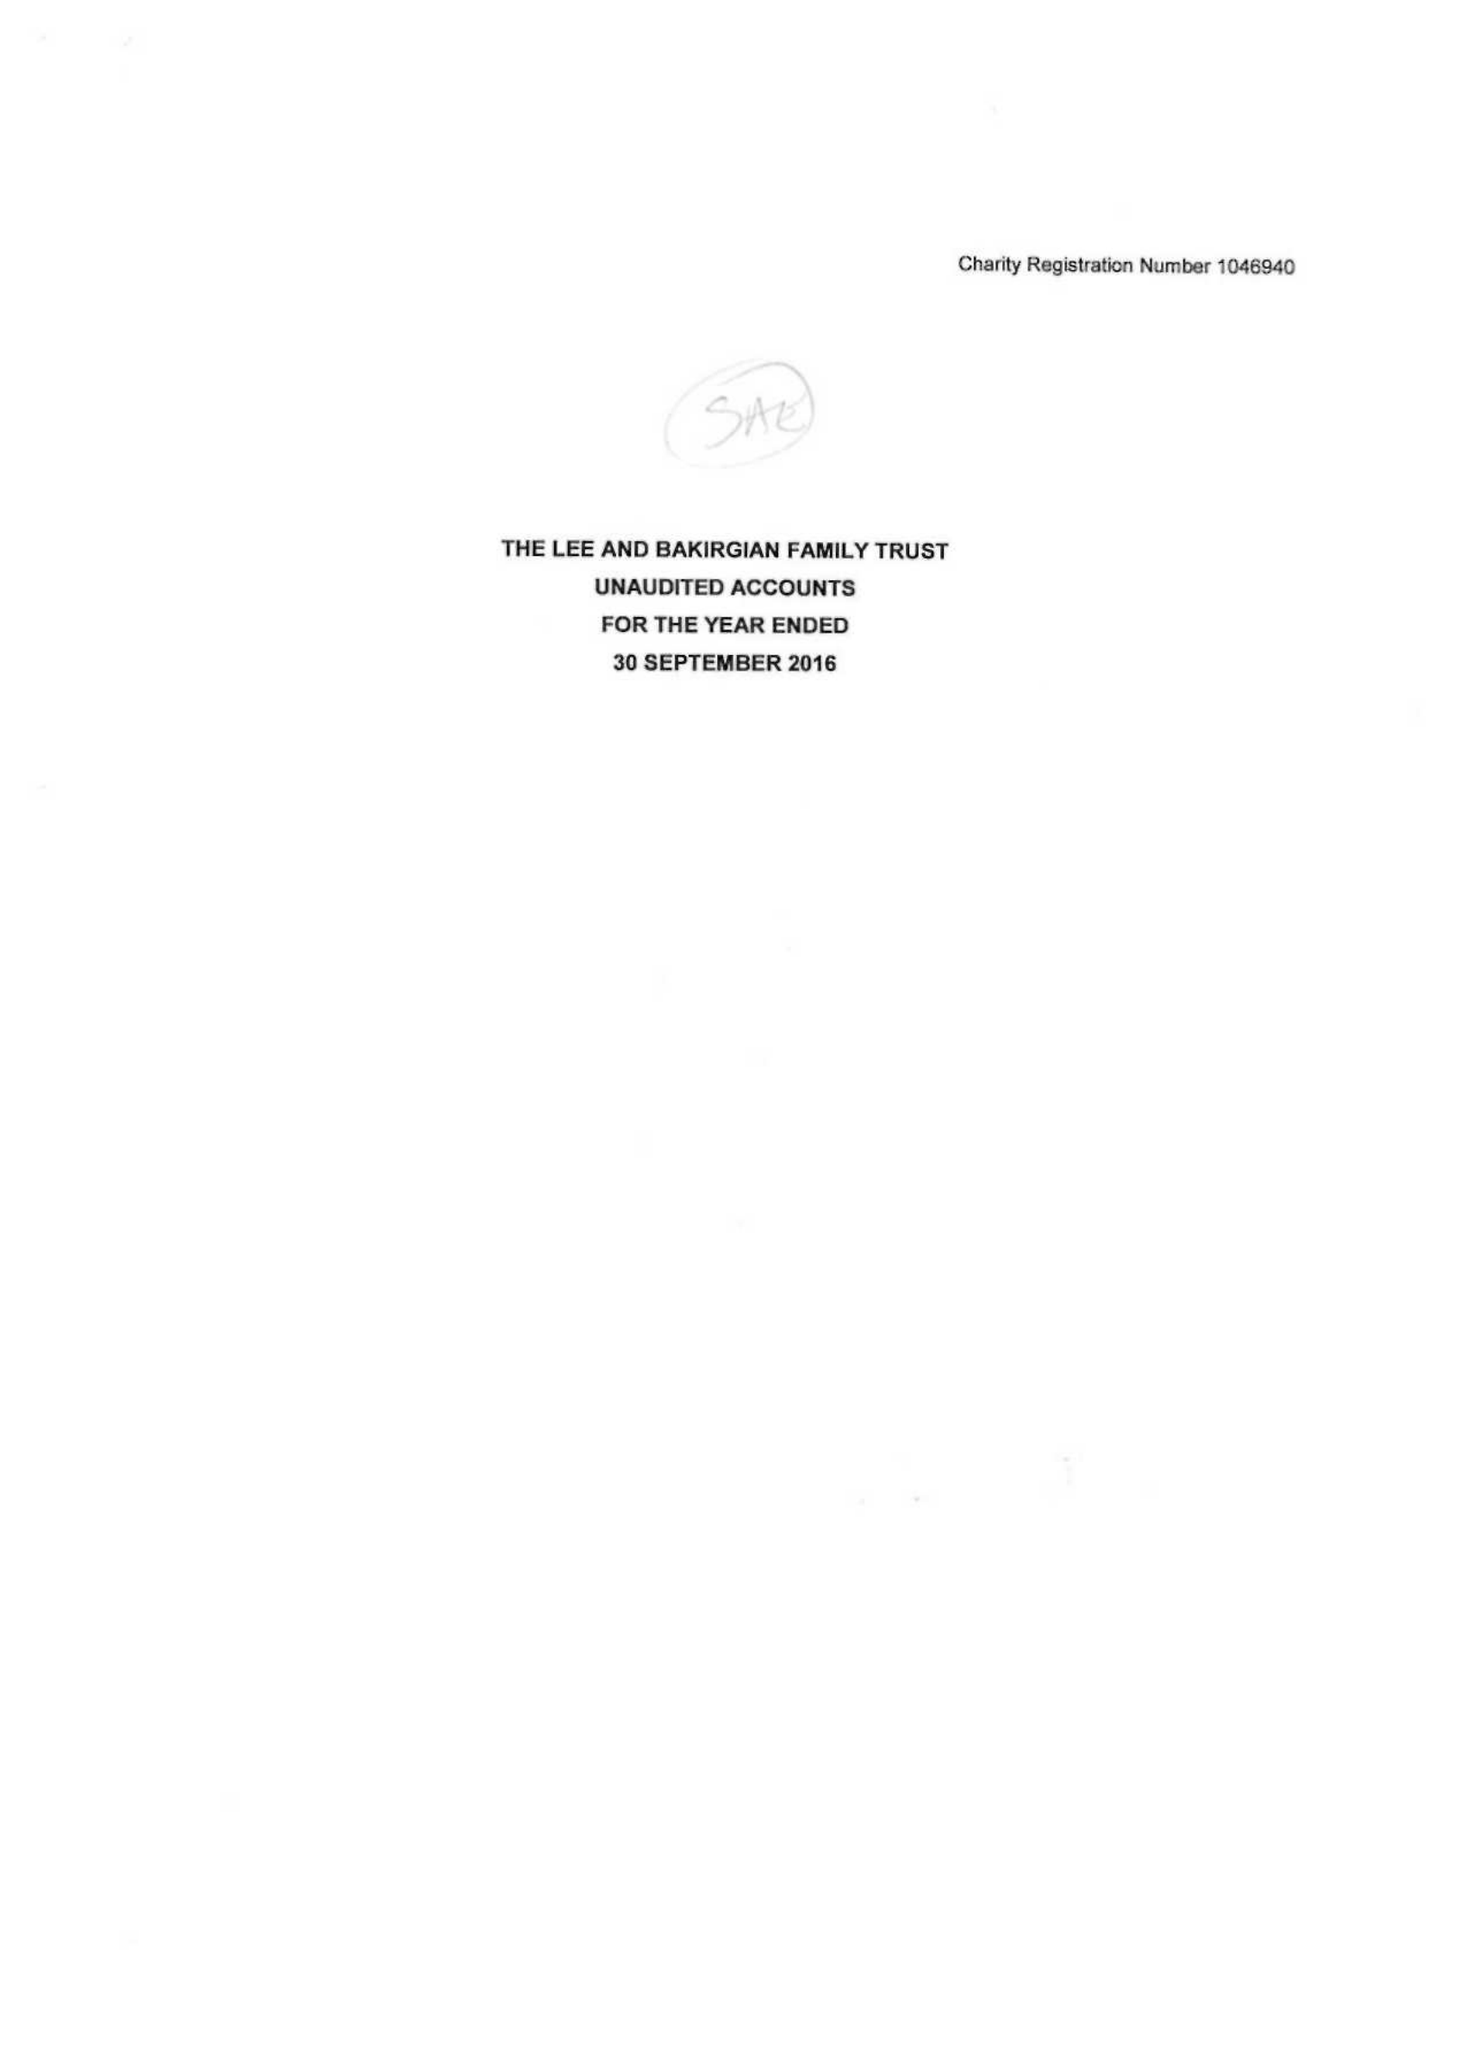What is the value for the address__post_town?
Answer the question using a single word or phrase. WARRINGTON 